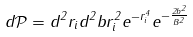<formula> <loc_0><loc_0><loc_500><loc_500>d \mathcal { P } = d ^ { 2 } r _ { i } d ^ { 2 } b r _ { i } ^ { 2 } e ^ { - r _ { i } ^ { 4 } } e ^ { - \frac { 2 b ^ { 2 } } { B ^ { 2 } } }</formula> 